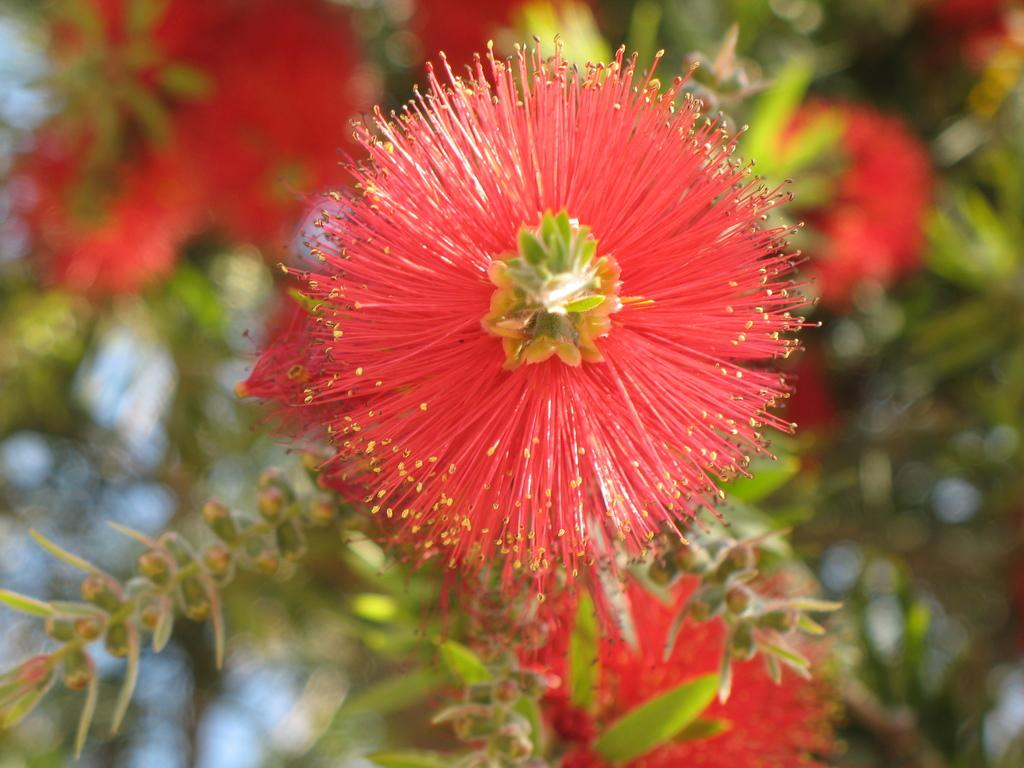What type of flower can be seen in the image? There is a red color flower in the image. What stage of growth are some of the flowers in the image? There are buds in the image. What else can be seen in the image besides flowers? There are leaves in the image. How are the leaves connected to the rest of the plant? The leaves are attached to stems. What can be seen in the background of the image? In the background of the image, more flowers and leaves are visible. What type of ear is visible in the image? There is no ear present in the image; it features a red color flower, buds, leaves, and stems. 